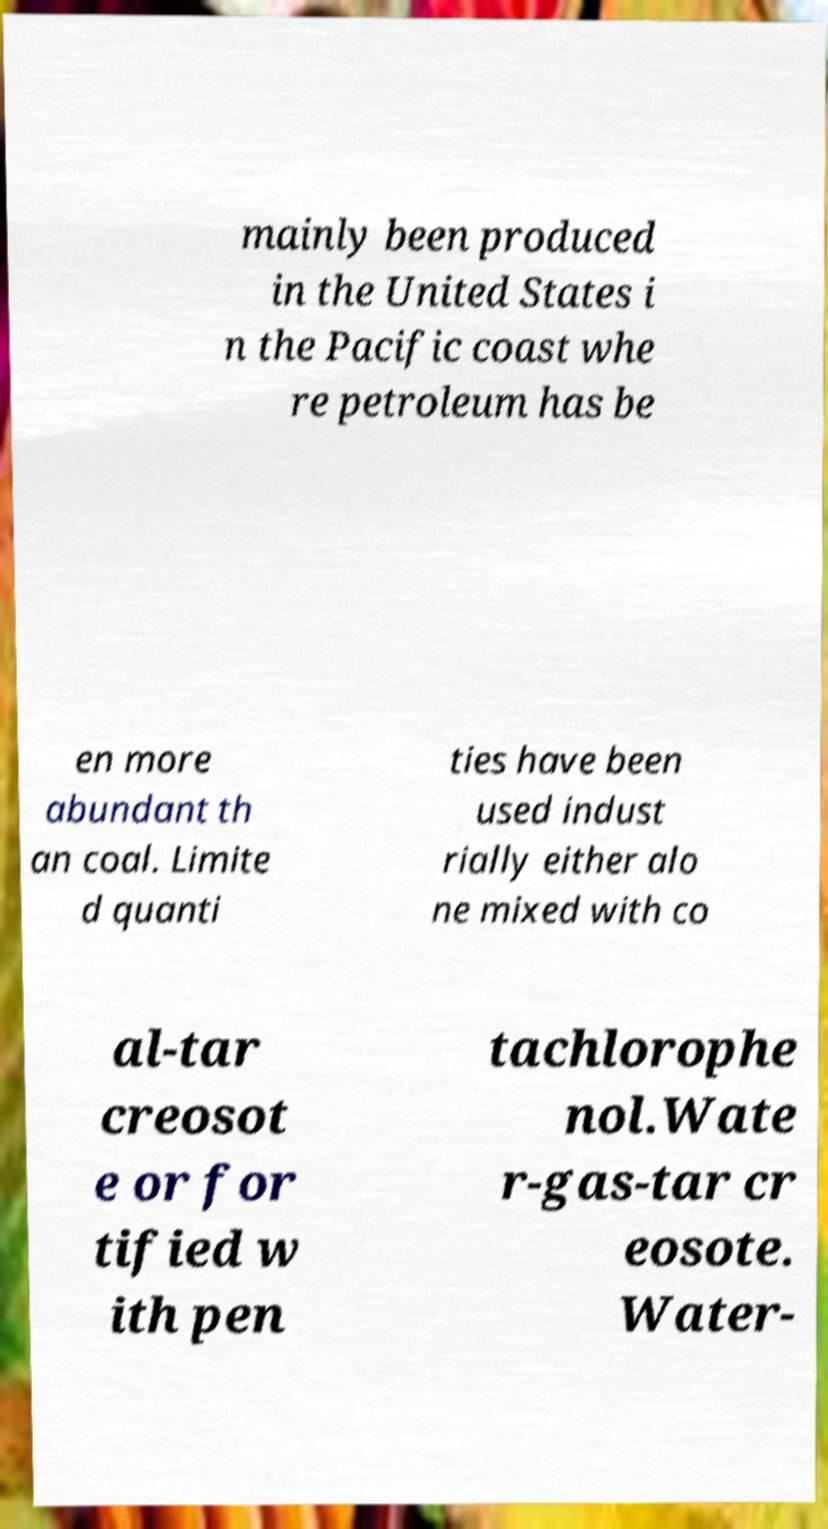Can you read and provide the text displayed in the image?This photo seems to have some interesting text. Can you extract and type it out for me? mainly been produced in the United States i n the Pacific coast whe re petroleum has be en more abundant th an coal. Limite d quanti ties have been used indust rially either alo ne mixed with co al-tar creosot e or for tified w ith pen tachlorophe nol.Wate r-gas-tar cr eosote. Water- 